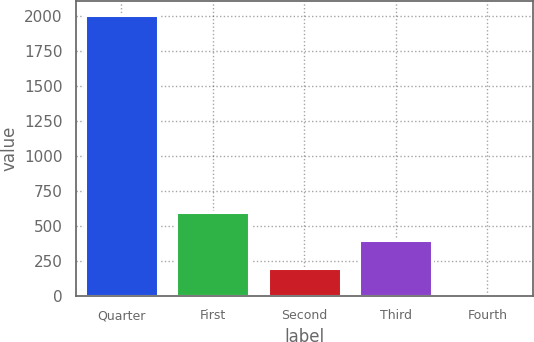Convert chart to OTSL. <chart><loc_0><loc_0><loc_500><loc_500><bar_chart><fcel>Quarter<fcel>First<fcel>Second<fcel>Third<fcel>Fourth<nl><fcel>2011<fcel>603.51<fcel>201.37<fcel>402.44<fcel>0.3<nl></chart> 